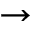<formula> <loc_0><loc_0><loc_500><loc_500>\to</formula> 